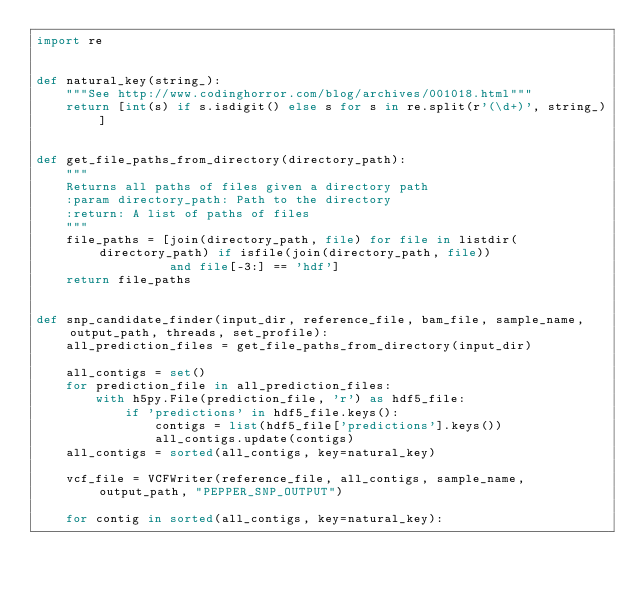<code> <loc_0><loc_0><loc_500><loc_500><_Python_>import re


def natural_key(string_):
    """See http://www.codinghorror.com/blog/archives/001018.html"""
    return [int(s) if s.isdigit() else s for s in re.split(r'(\d+)', string_)]


def get_file_paths_from_directory(directory_path):
    """
    Returns all paths of files given a directory path
    :param directory_path: Path to the directory
    :return: A list of paths of files
    """
    file_paths = [join(directory_path, file) for file in listdir(directory_path) if isfile(join(directory_path, file))
                  and file[-3:] == 'hdf']
    return file_paths


def snp_candidate_finder(input_dir, reference_file, bam_file, sample_name, output_path, threads, set_profile):
    all_prediction_files = get_file_paths_from_directory(input_dir)

    all_contigs = set()
    for prediction_file in all_prediction_files:
        with h5py.File(prediction_file, 'r') as hdf5_file:
            if 'predictions' in hdf5_file.keys():
                contigs = list(hdf5_file['predictions'].keys())
                all_contigs.update(contigs)
    all_contigs = sorted(all_contigs, key=natural_key)

    vcf_file = VCFWriter(reference_file, all_contigs, sample_name, output_path, "PEPPER_SNP_OUTPUT")

    for contig in sorted(all_contigs, key=natural_key):</code> 